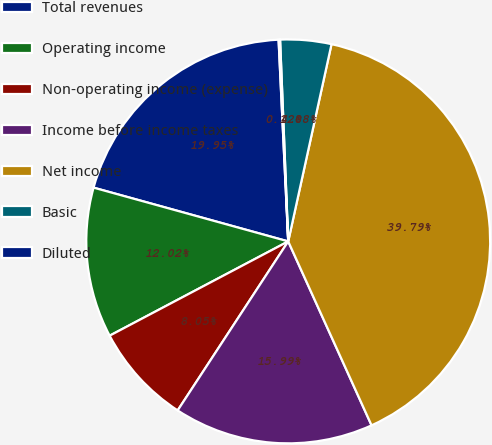<chart> <loc_0><loc_0><loc_500><loc_500><pie_chart><fcel>Total revenues<fcel>Operating income<fcel>Non-operating income (expense)<fcel>Income before income taxes<fcel>Net income<fcel>Basic<fcel>Diluted<nl><fcel>19.95%<fcel>12.02%<fcel>8.05%<fcel>15.99%<fcel>39.79%<fcel>4.08%<fcel>0.12%<nl></chart> 